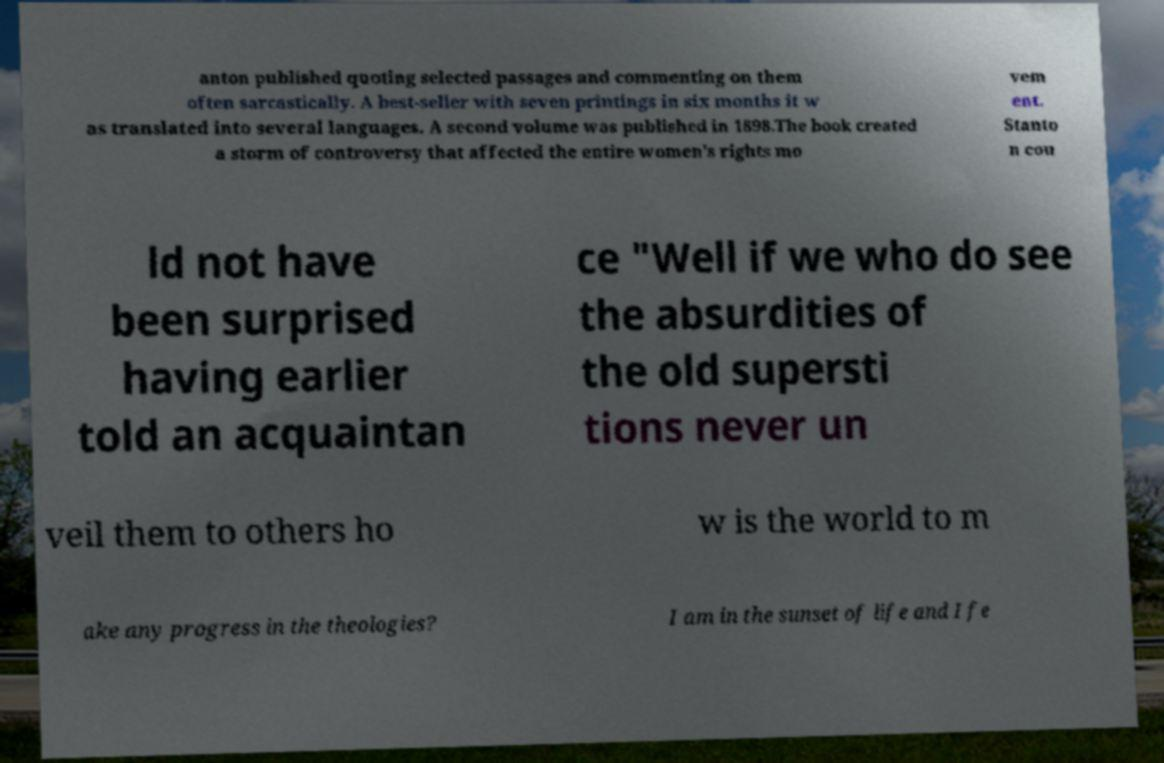I need the written content from this picture converted into text. Can you do that? anton published quoting selected passages and commenting on them often sarcastically. A best-seller with seven printings in six months it w as translated into several languages. A second volume was published in 1898.The book created a storm of controversy that affected the entire women's rights mo vem ent. Stanto n cou ld not have been surprised having earlier told an acquaintan ce "Well if we who do see the absurdities of the old supersti tions never un veil them to others ho w is the world to m ake any progress in the theologies? I am in the sunset of life and I fe 